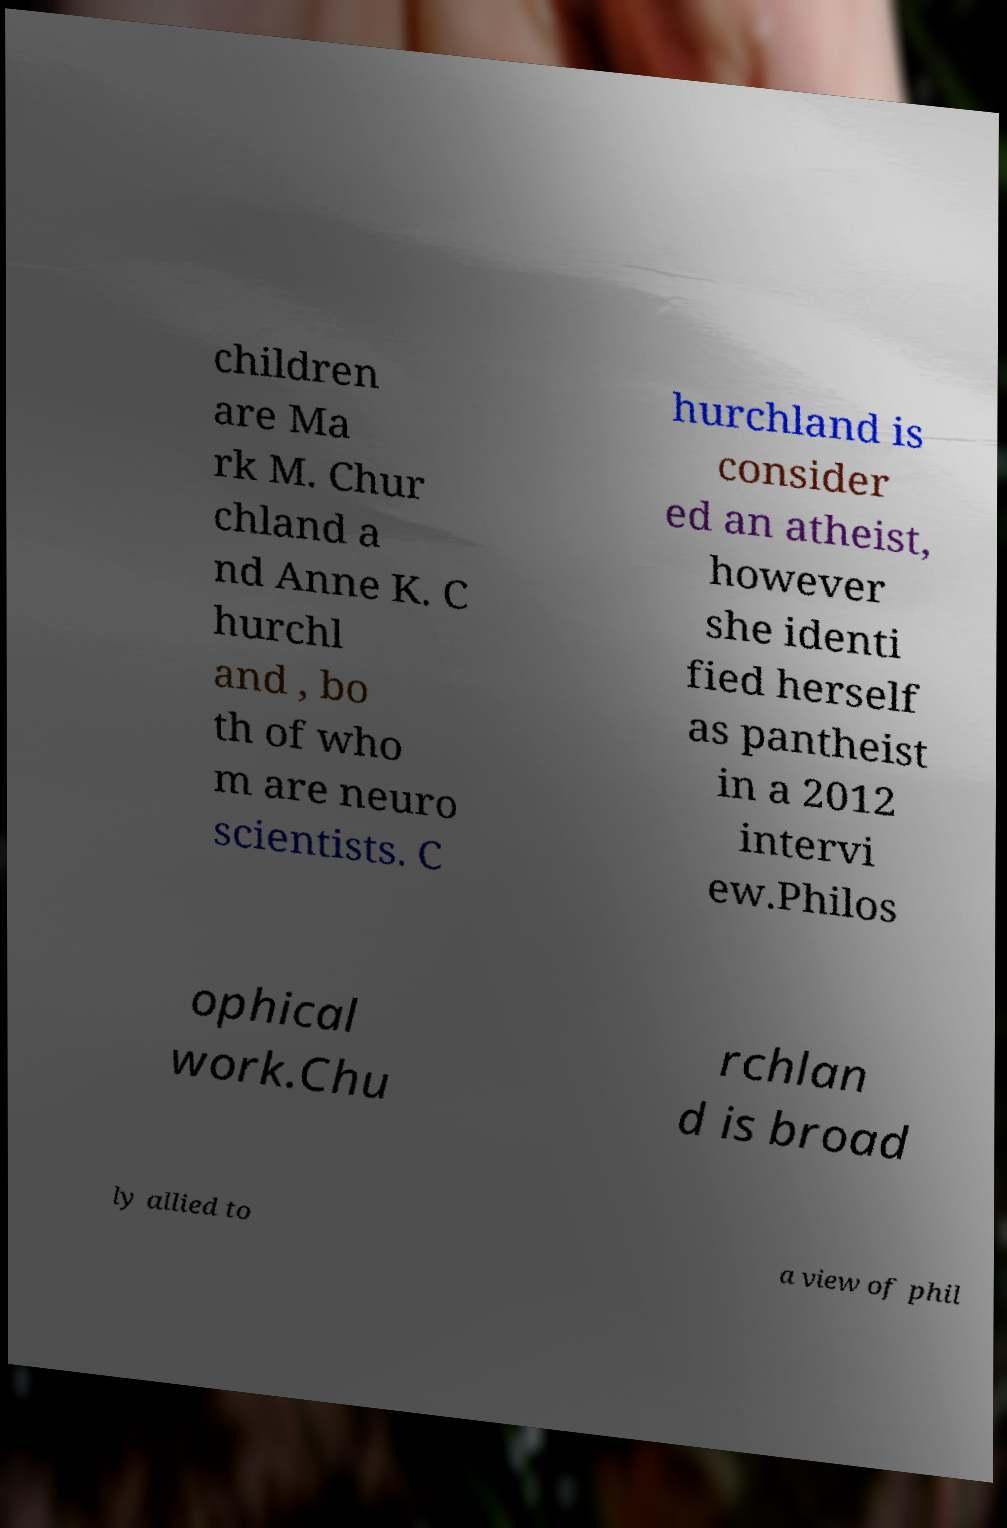For documentation purposes, I need the text within this image transcribed. Could you provide that? children are Ma rk M. Chur chland a nd Anne K. C hurchl and , bo th of who m are neuro scientists. C hurchland is consider ed an atheist, however she identi fied herself as pantheist in a 2012 intervi ew.Philos ophical work.Chu rchlan d is broad ly allied to a view of phil 